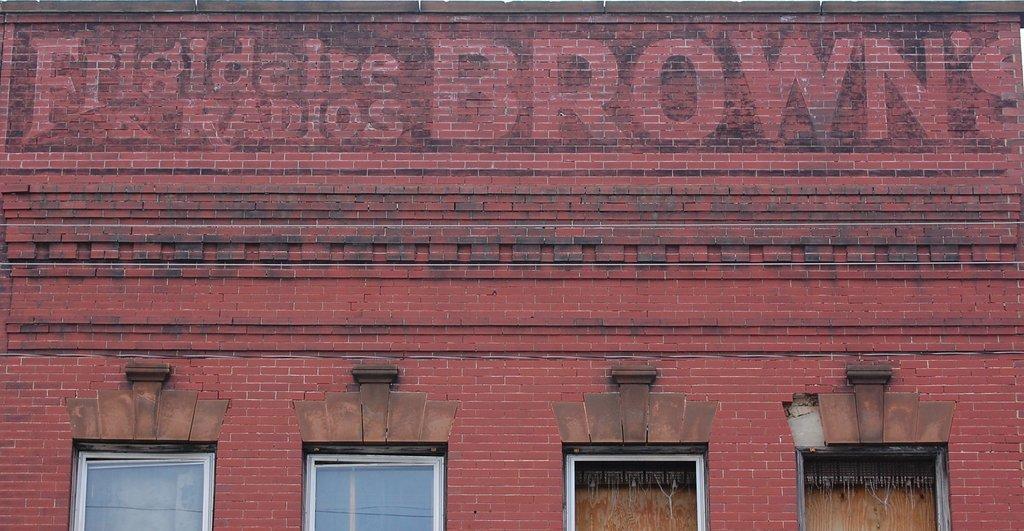Can you describe this image briefly? In this image in the middle, there is a building on that there are windows, glasses, text and wall. 